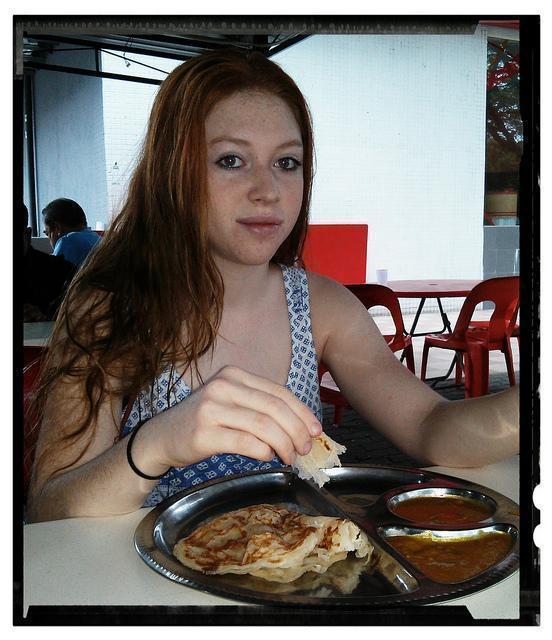What kind of bread is this?
Select the correct answer and articulate reasoning with the following format: 'Answer: answer
Rationale: rationale.'
Options: Rye, white, naan, wheat. Answer: naan.
Rationale: It's naan bread 